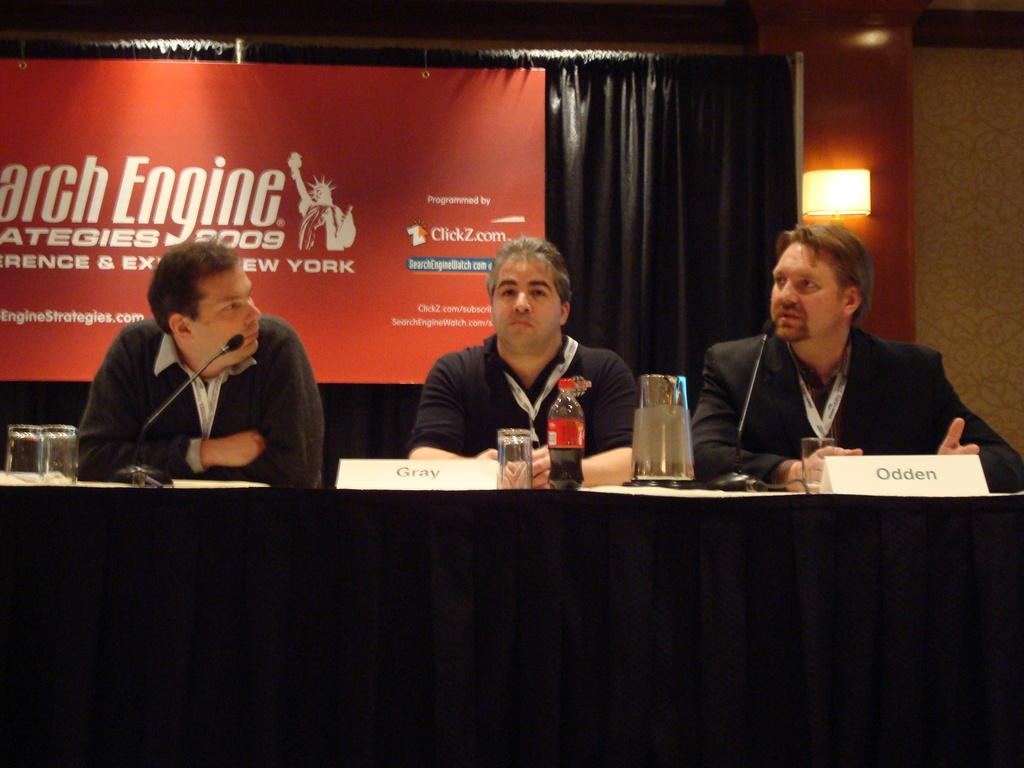<image>
Relay a brief, clear account of the picture shown. Men sit at a table in front of a banner that advertises Search Engine Strategies 2009. 